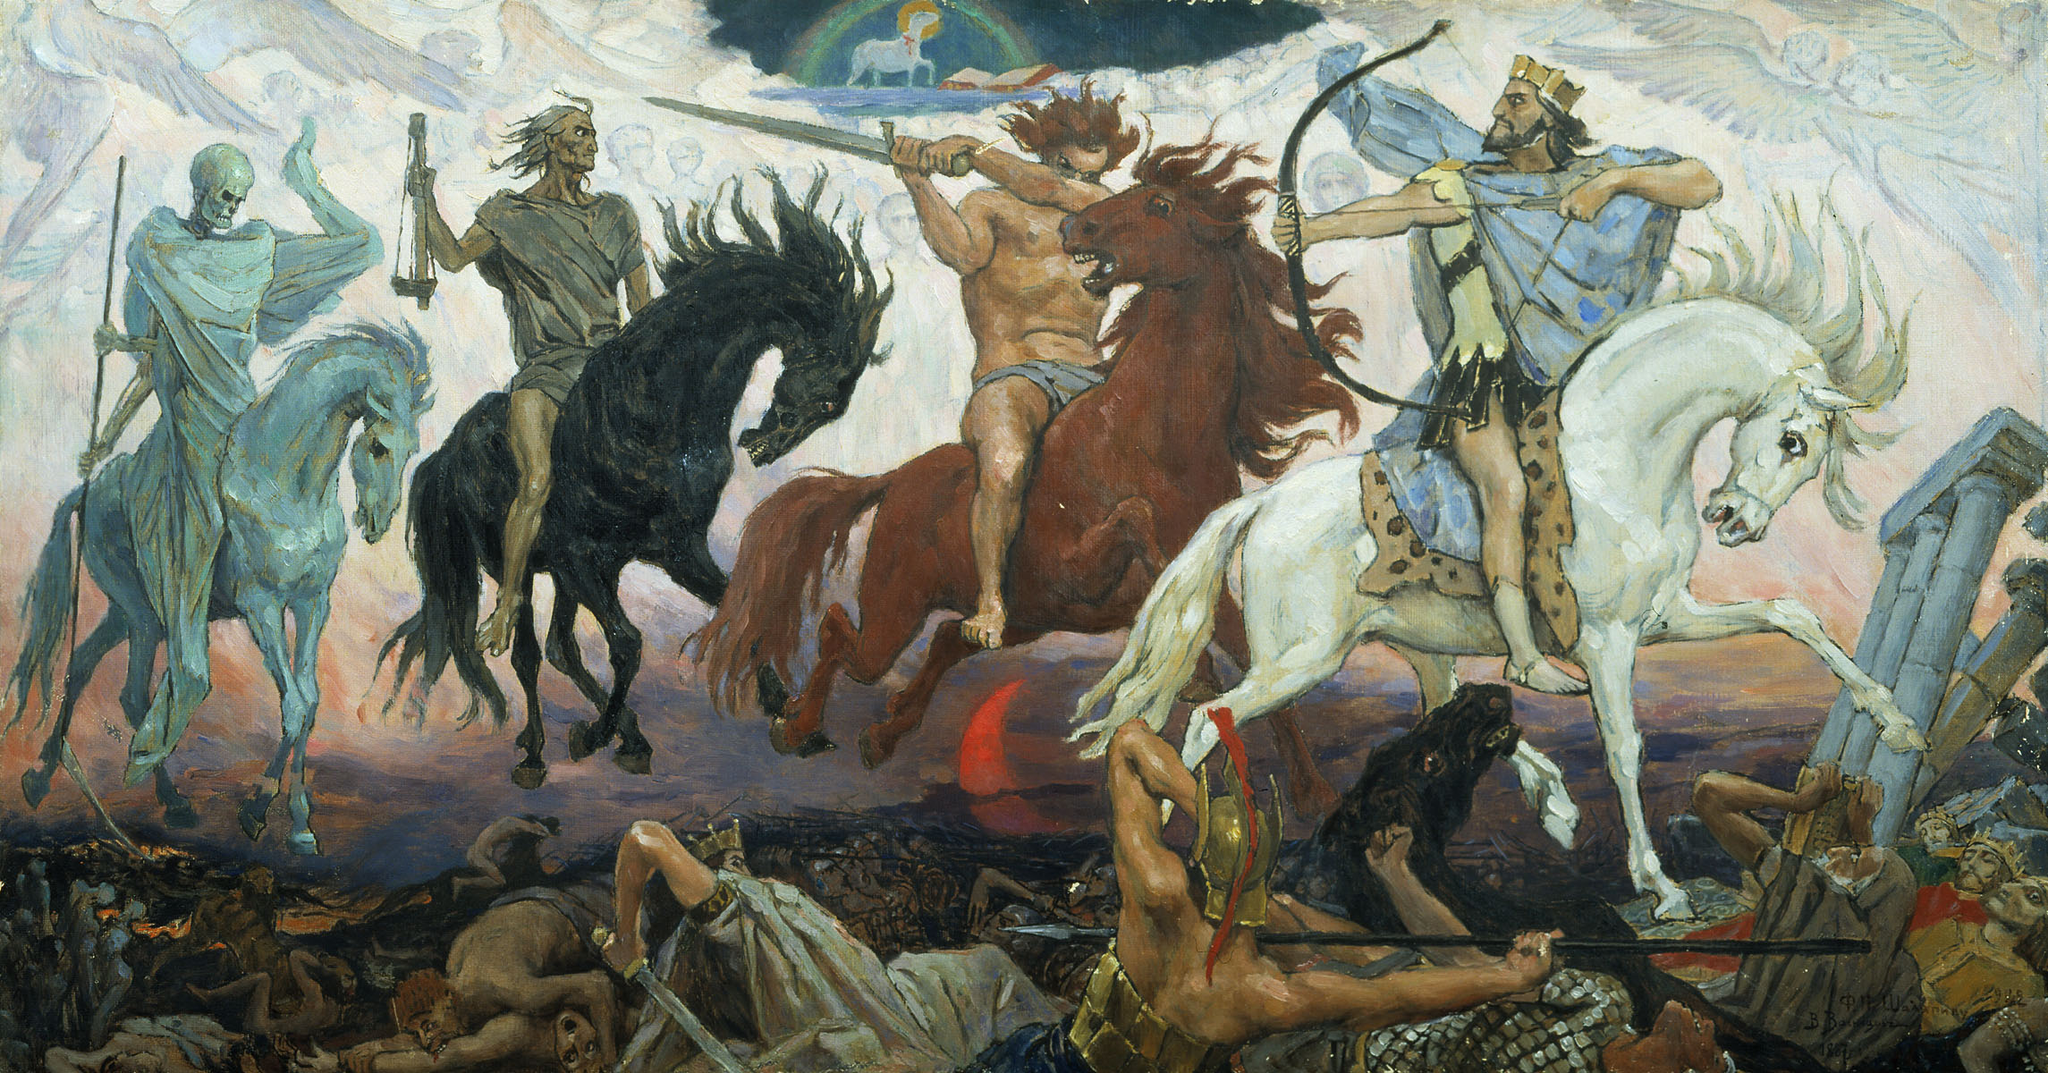Write a detailed description of the given image. The image is a vibrant depiction of a mythological battle scene, characterized by dynamic action and dramatic use of color. Four central figures are depicted riding horses, each radiating a unique aura. From left to right, there's a skeletal figure in blue, a bare-chested warrior wielding a sword atop a fiery red steed, a figure in regal attire on a white horse, and a rod-bearing king-like figure on a light blue horse. The background is chaotic, with fallen warriors and dark, ominous clouds, possibly indicating a scene from a famous epic or myth. The dramatic lighting and the fluid motion of the horses and figures give this painting a sense of impending doom and heroic strife. This dramatic tableau is possibly inspired by historical or mythological wars and reflects the Baroque style, known for its focus on motion, detail, and emotional intensity. 